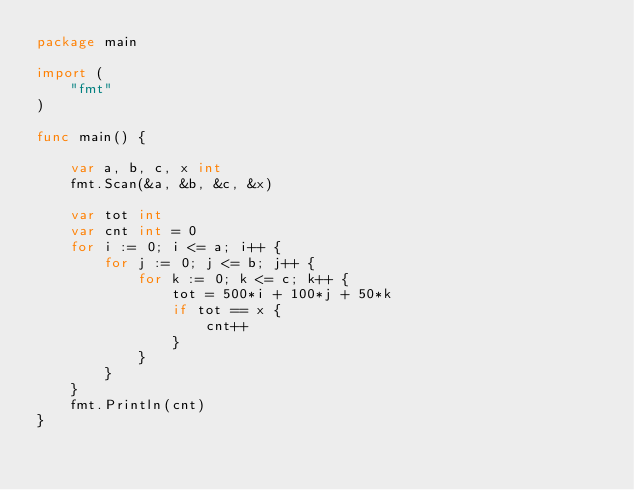Convert code to text. <code><loc_0><loc_0><loc_500><loc_500><_Go_>package main

import (
	"fmt"
)

func main() {

	var a, b, c, x int
	fmt.Scan(&a, &b, &c, &x)

	var tot int
	var cnt int = 0
	for i := 0; i <= a; i++ {
		for j := 0; j <= b; j++ {
			for k := 0; k <= c; k++ {
				tot = 500*i + 100*j + 50*k
				if tot == x {
					cnt++
				}
			}
		}
	}
	fmt.Println(cnt)
}
</code> 